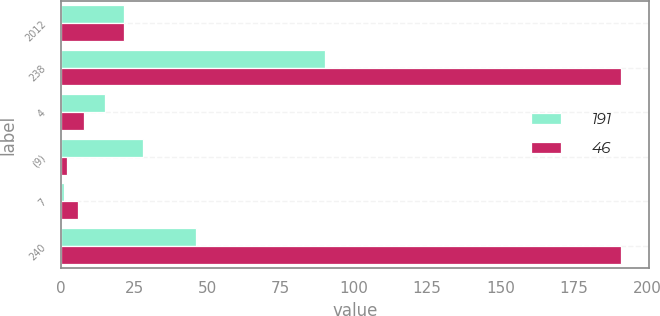<chart> <loc_0><loc_0><loc_500><loc_500><stacked_bar_chart><ecel><fcel>2012<fcel>238<fcel>4<fcel>(9)<fcel>7<fcel>240<nl><fcel>191<fcel>21.5<fcel>90<fcel>15<fcel>28<fcel>1<fcel>46<nl><fcel>46<fcel>21.5<fcel>191<fcel>8<fcel>2<fcel>6<fcel>191<nl></chart> 